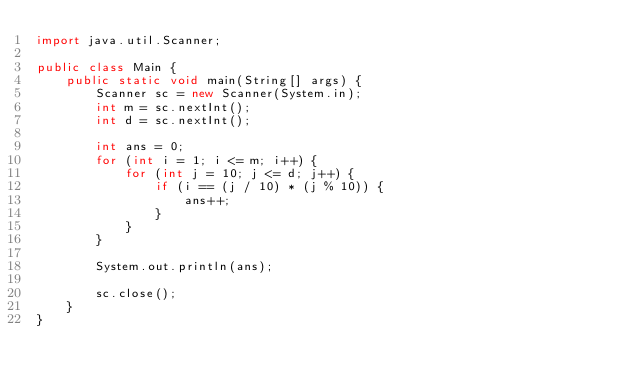<code> <loc_0><loc_0><loc_500><loc_500><_Java_>import java.util.Scanner;

public class Main {
	public static void main(String[] args) {
		Scanner sc = new Scanner(System.in);
		int m = sc.nextInt();
		int d = sc.nextInt();

		int ans = 0;
		for (int i = 1; i <= m; i++) {
			for (int j = 10; j <= d; j++) {
				if (i == (j / 10) * (j % 10)) {
					ans++;
				}
			}
		}

		System.out.println(ans);

		sc.close();
	}
}
</code> 